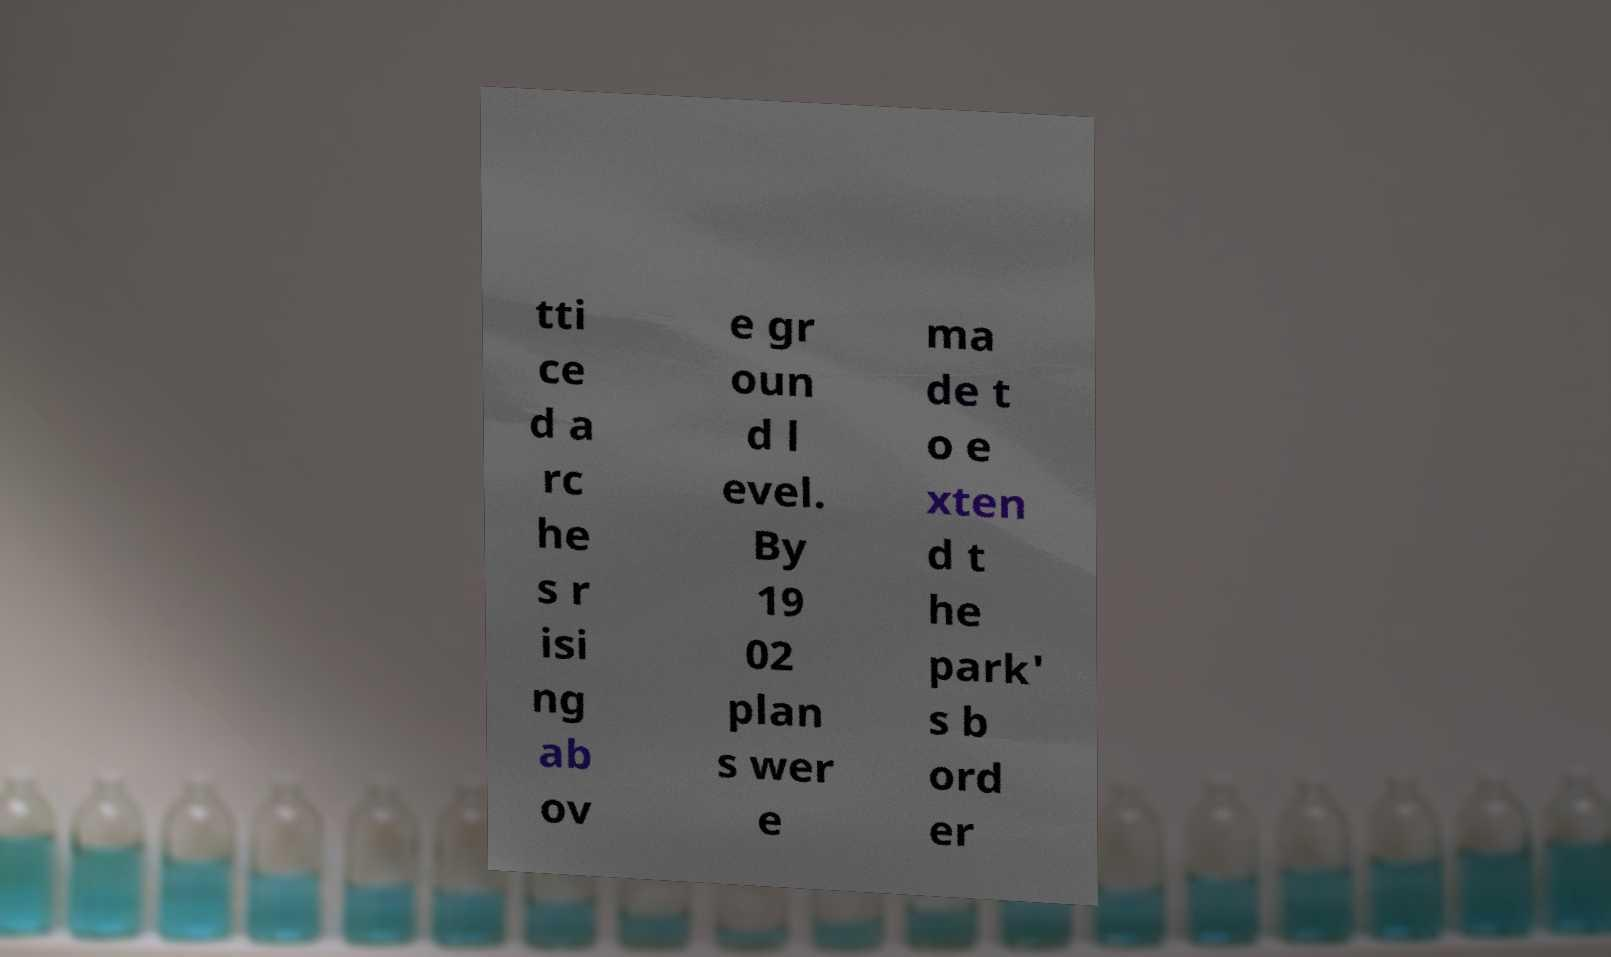What messages or text are displayed in this image? I need them in a readable, typed format. tti ce d a rc he s r isi ng ab ov e gr oun d l evel. By 19 02 plan s wer e ma de t o e xten d t he park' s b ord er 